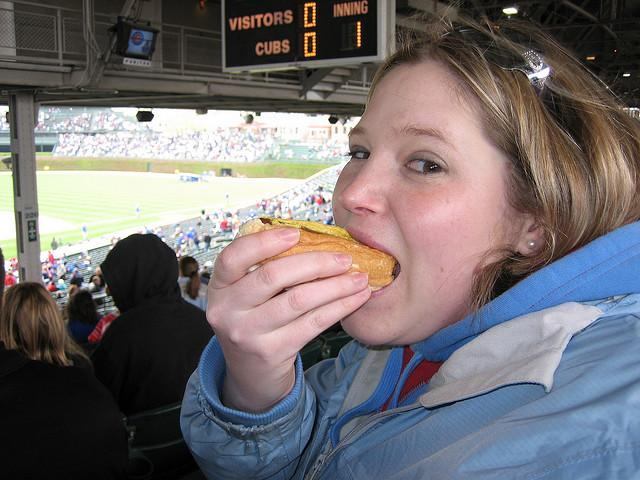The condiment on this food comes from where? seeds 